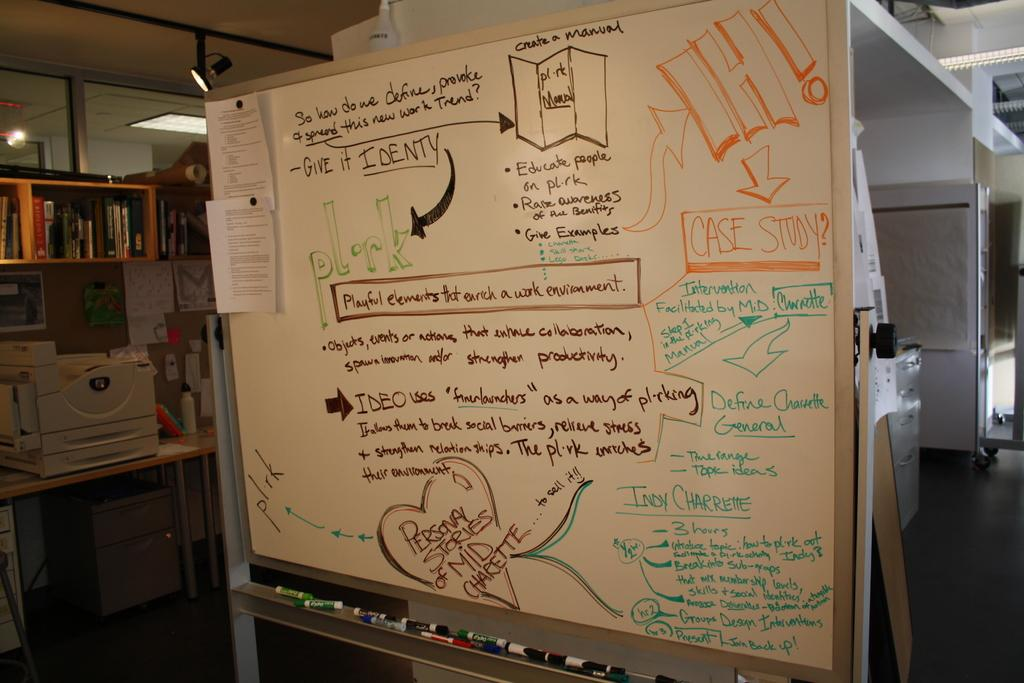<image>
Provide a brief description of the given image. A white board that has Give It Identy (sic) on it. 